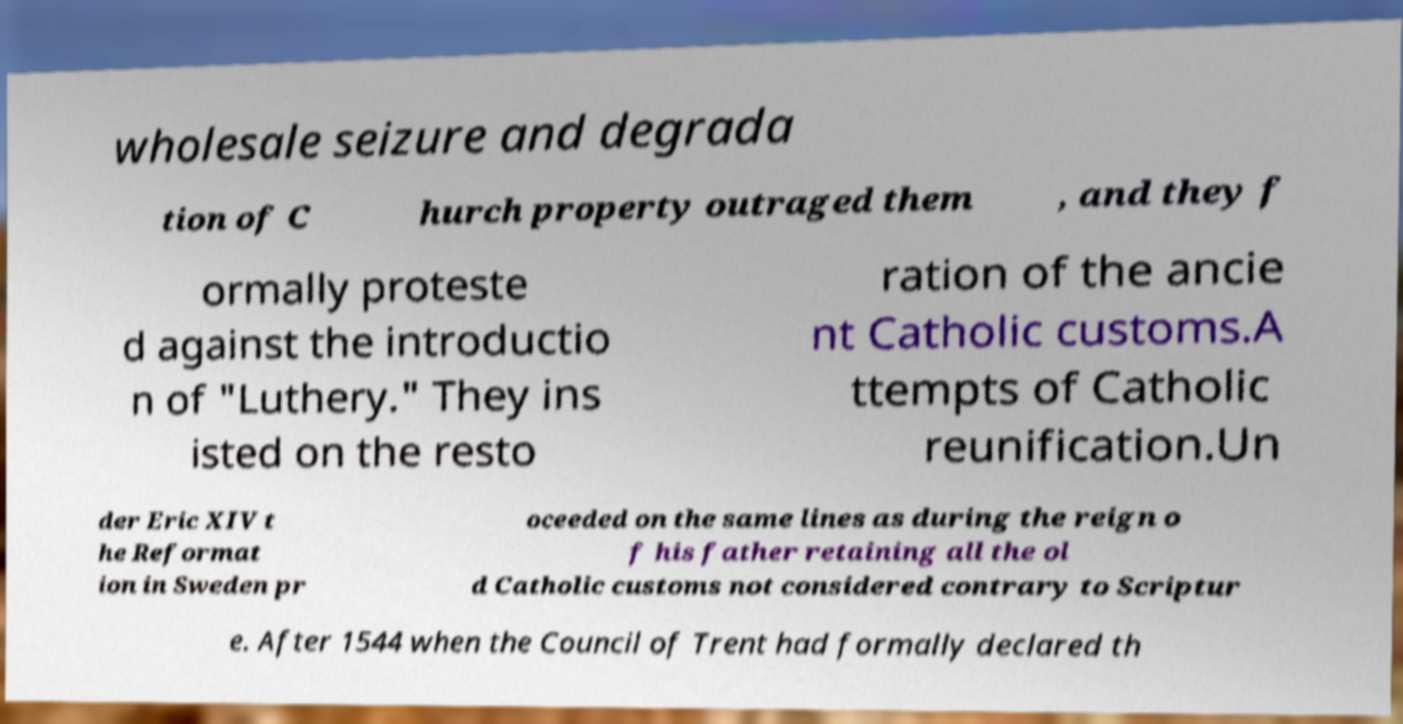Can you read and provide the text displayed in the image?This photo seems to have some interesting text. Can you extract and type it out for me? wholesale seizure and degrada tion of C hurch property outraged them , and they f ormally proteste d against the introductio n of "Luthery." They ins isted on the resto ration of the ancie nt Catholic customs.A ttempts of Catholic reunification.Un der Eric XIV t he Reformat ion in Sweden pr oceeded on the same lines as during the reign o f his father retaining all the ol d Catholic customs not considered contrary to Scriptur e. After 1544 when the Council of Trent had formally declared th 